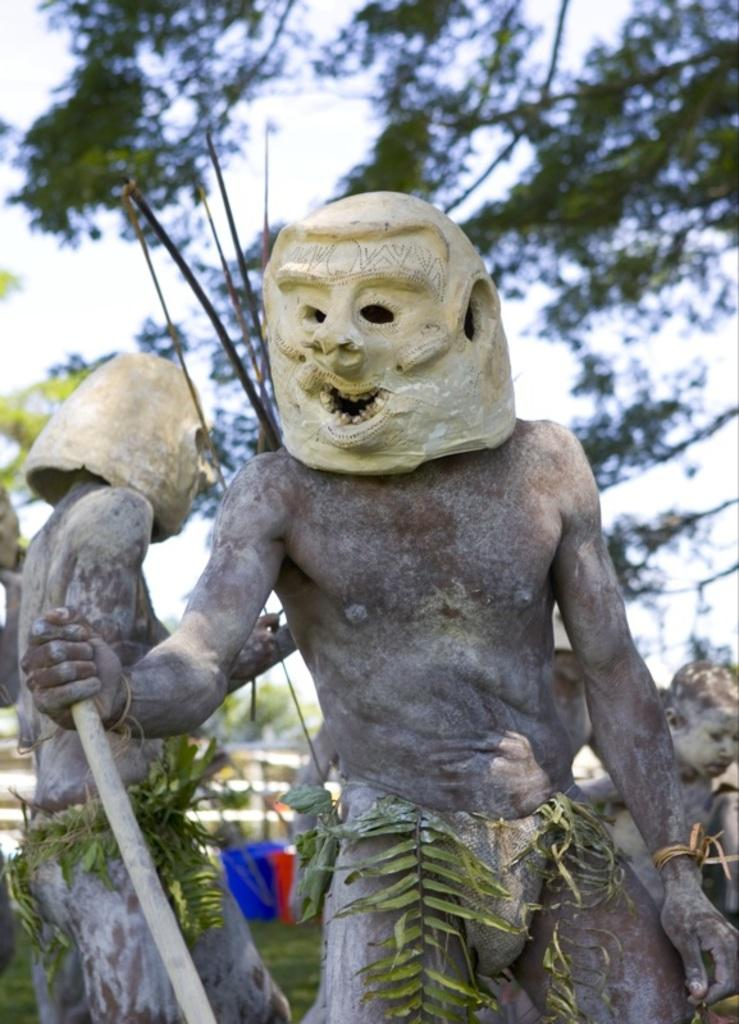What is the main object in the image? There is a stick in the image. What else can be seen in the image besides the stick? There are leaves, statues, grass, objects, trees, and the sky visible in the image. Can you describe the background of the image? The background of the image includes grass, objects, trees, and the sky. What type of day is depicted in the image? The provided facts do not mention any specific day or weather conditions, so it cannot be determined from the image. 